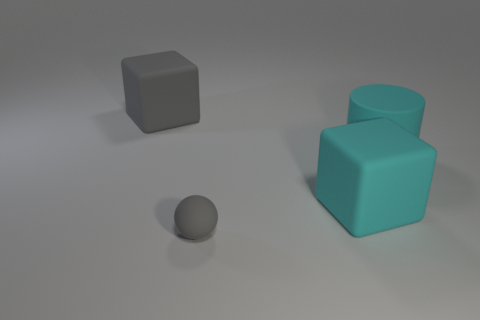What material is the big block that is the same color as the small thing?
Make the answer very short. Rubber. How many gray matte spheres are there?
Offer a very short reply. 1. Are there fewer rubber blocks than large cyan cylinders?
Offer a very short reply. No. There is another cube that is the same size as the gray rubber block; what is it made of?
Make the answer very short. Rubber. What number of things are either large cyan rubber blocks or tiny red cylinders?
Give a very brief answer. 1. How many matte things are left of the large cyan matte cylinder and behind the large cyan rubber block?
Give a very brief answer. 1. Is the number of cyan matte things that are to the left of the gray ball less than the number of matte balls?
Provide a succinct answer. Yes. There is a cyan thing that is the same size as the cyan block; what shape is it?
Offer a terse response. Cylinder. How many other objects are there of the same color as the big rubber cylinder?
Your answer should be very brief. 1. Do the gray block and the cyan rubber cylinder have the same size?
Your answer should be very brief. Yes. 